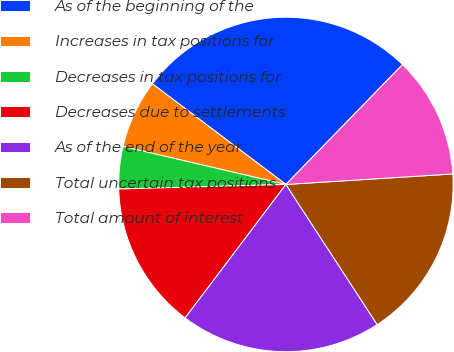<chart> <loc_0><loc_0><loc_500><loc_500><pie_chart><fcel>As of the beginning of the<fcel>Increases in tax positions for<fcel>Decreases in tax positions for<fcel>Decreases due to settlements<fcel>As of the end of the year<fcel>Total uncertain tax positions<fcel>Total amount of interest<nl><fcel>27.0%<fcel>6.63%<fcel>4.08%<fcel>14.27%<fcel>19.48%<fcel>16.81%<fcel>11.72%<nl></chart> 